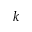Convert formula to latex. <formula><loc_0><loc_0><loc_500><loc_500>k</formula> 